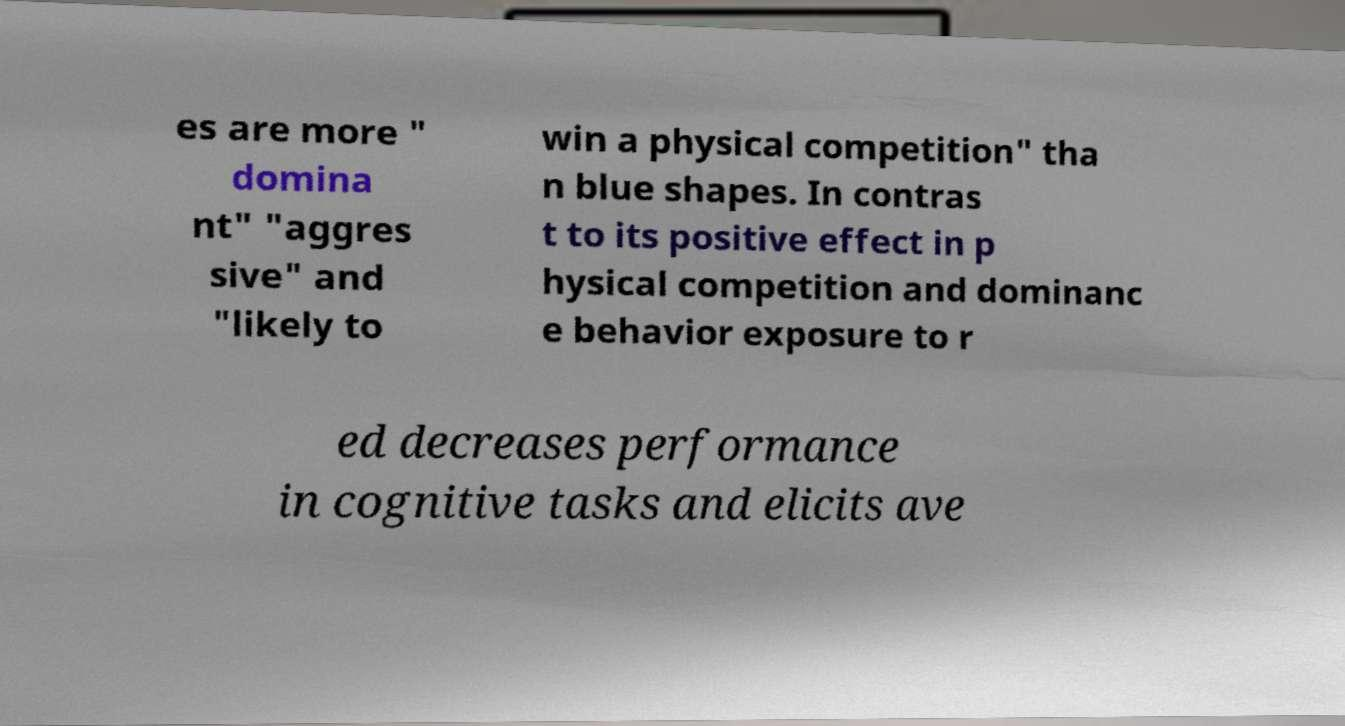Please identify and transcribe the text found in this image. es are more " domina nt" "aggres sive" and "likely to win a physical competition" tha n blue shapes. In contras t to its positive effect in p hysical competition and dominanc e behavior exposure to r ed decreases performance in cognitive tasks and elicits ave 